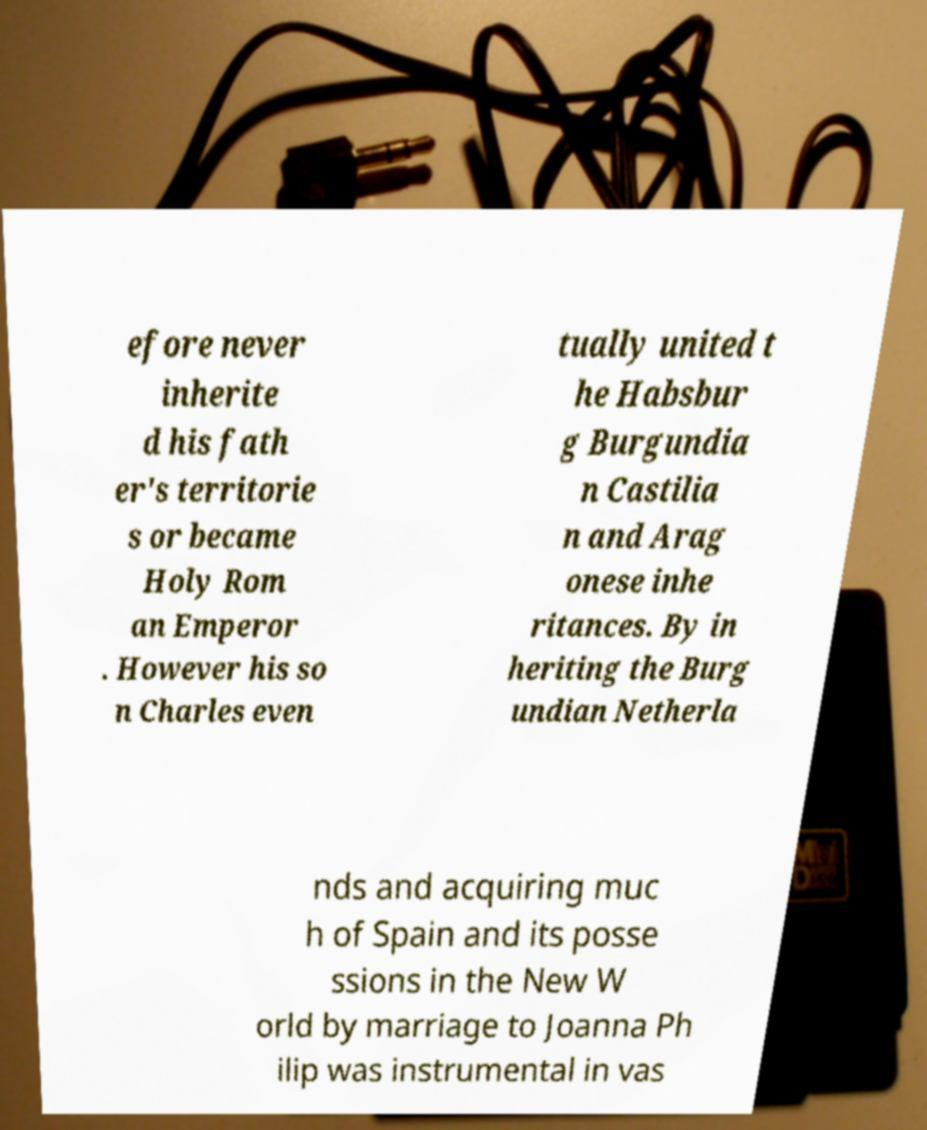Can you read and provide the text displayed in the image?This photo seems to have some interesting text. Can you extract and type it out for me? efore never inherite d his fath er's territorie s or became Holy Rom an Emperor . However his so n Charles even tually united t he Habsbur g Burgundia n Castilia n and Arag onese inhe ritances. By in heriting the Burg undian Netherla nds and acquiring muc h of Spain and its posse ssions in the New W orld by marriage to Joanna Ph ilip was instrumental in vas 